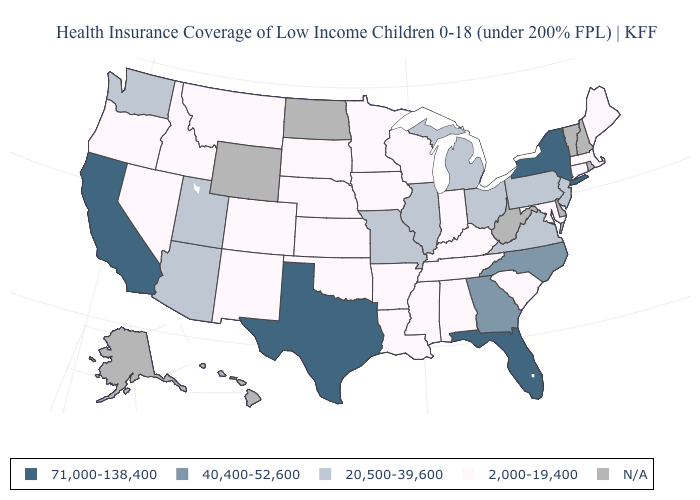Name the states that have a value in the range 20,500-39,600?
Short answer required. Arizona, Illinois, Michigan, Missouri, New Jersey, Ohio, Pennsylvania, Utah, Virginia, Washington. What is the value of Washington?
Give a very brief answer. 20,500-39,600. What is the highest value in the West ?
Give a very brief answer. 71,000-138,400. Name the states that have a value in the range 71,000-138,400?
Short answer required. California, Florida, New York, Texas. What is the value of Colorado?
Write a very short answer. 2,000-19,400. Name the states that have a value in the range N/A?
Give a very brief answer. Alaska, Delaware, Hawaii, New Hampshire, North Dakota, Rhode Island, Vermont, West Virginia, Wyoming. Which states have the lowest value in the USA?
Keep it brief. Alabama, Arkansas, Colorado, Connecticut, Idaho, Indiana, Iowa, Kansas, Kentucky, Louisiana, Maine, Maryland, Massachusetts, Minnesota, Mississippi, Montana, Nebraska, Nevada, New Mexico, Oklahoma, Oregon, South Carolina, South Dakota, Tennessee, Wisconsin. What is the highest value in the South ?
Short answer required. 71,000-138,400. Which states hav the highest value in the MidWest?
Write a very short answer. Illinois, Michigan, Missouri, Ohio. Name the states that have a value in the range N/A?
Give a very brief answer. Alaska, Delaware, Hawaii, New Hampshire, North Dakota, Rhode Island, Vermont, West Virginia, Wyoming. What is the value of New Jersey?
Concise answer only. 20,500-39,600. What is the lowest value in the West?
Quick response, please. 2,000-19,400. Does the first symbol in the legend represent the smallest category?
Keep it brief. No. Which states have the lowest value in the USA?
Keep it brief. Alabama, Arkansas, Colorado, Connecticut, Idaho, Indiana, Iowa, Kansas, Kentucky, Louisiana, Maine, Maryland, Massachusetts, Minnesota, Mississippi, Montana, Nebraska, Nevada, New Mexico, Oklahoma, Oregon, South Carolina, South Dakota, Tennessee, Wisconsin. 